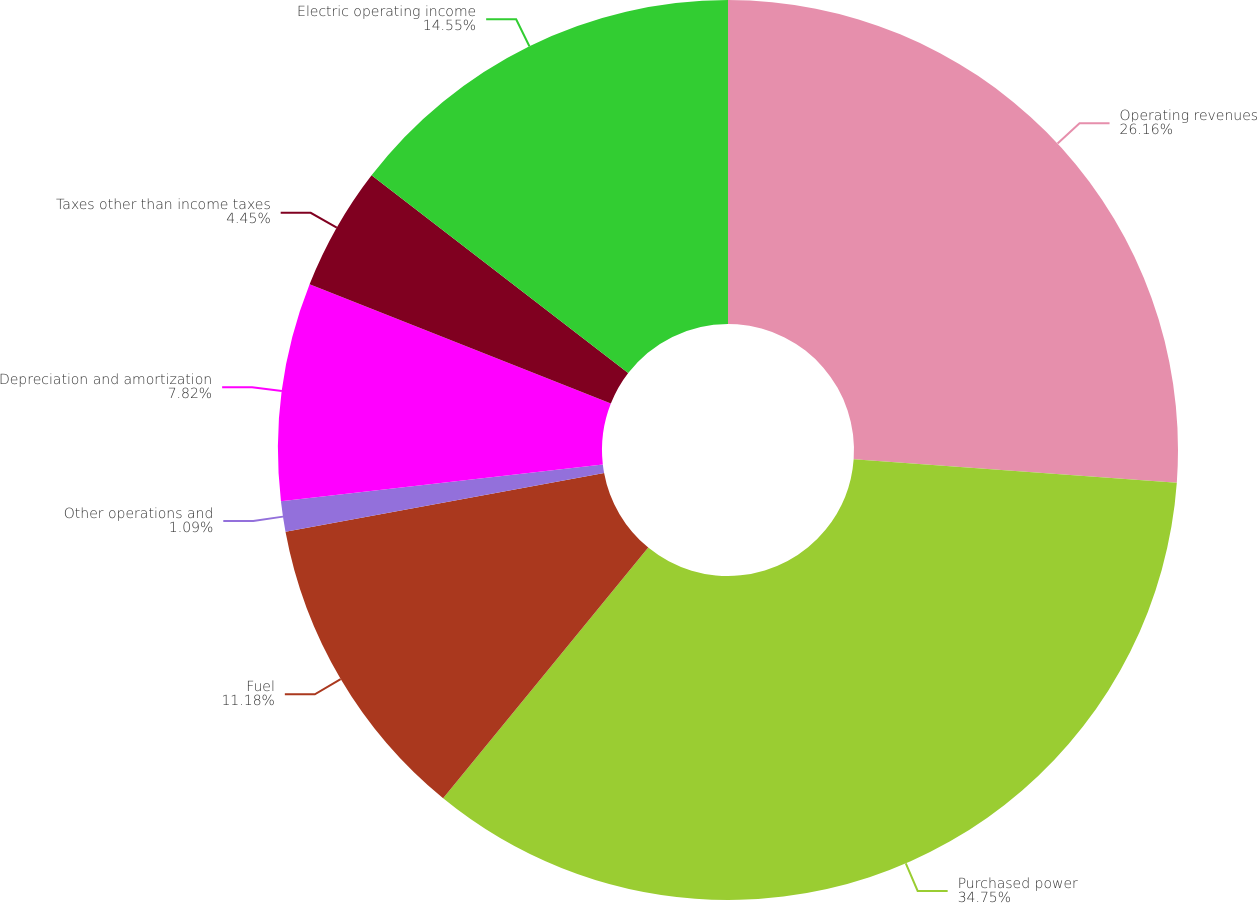Convert chart. <chart><loc_0><loc_0><loc_500><loc_500><pie_chart><fcel>Operating revenues<fcel>Purchased power<fcel>Fuel<fcel>Other operations and<fcel>Depreciation and amortization<fcel>Taxes other than income taxes<fcel>Electric operating income<nl><fcel>26.16%<fcel>34.75%<fcel>11.18%<fcel>1.09%<fcel>7.82%<fcel>4.45%<fcel>14.55%<nl></chart> 